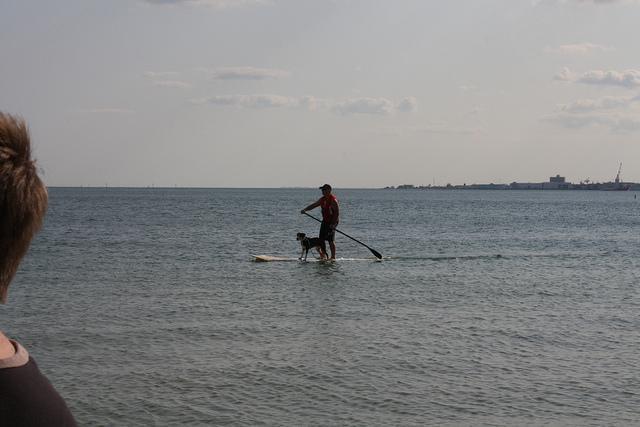What type of vehicle is present in the water?
Answer the question by selecting the correct answer among the 4 following choices and explain your choice with a short sentence. The answer should be formatted with the following format: `Answer: choice
Rationale: rationale.`
Options: Board, bicycle, truck, car. Answer: board.
Rationale: The man and dog are on a paddle board. 